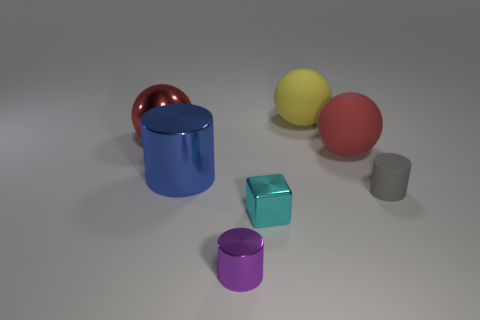Does the metallic cylinder in front of the small gray matte object have the same size as the rubber object that is in front of the large red rubber object?
Your response must be concise. Yes. There is a matte object right of the big red object that is in front of the red metallic ball; what is its shape?
Make the answer very short. Cylinder. How many red rubber objects are right of the big cylinder?
Make the answer very short. 1. What is the color of the sphere that is made of the same material as the blue cylinder?
Offer a terse response. Red. There is a metal sphere; is it the same size as the metallic cylinder that is behind the tiny gray object?
Ensure brevity in your answer.  Yes. How big is the purple thing in front of the red sphere on the left side of the small cylinder that is left of the small gray object?
Your answer should be compact. Small. How many shiny objects are brown blocks or yellow things?
Your response must be concise. 0. The rubber sphere in front of the big metallic ball is what color?
Give a very brief answer. Red. There is a red rubber thing that is the same size as the blue shiny thing; what shape is it?
Offer a very short reply. Sphere. There is a large metal ball; does it have the same color as the matte sphere in front of the metallic ball?
Offer a very short reply. Yes. 